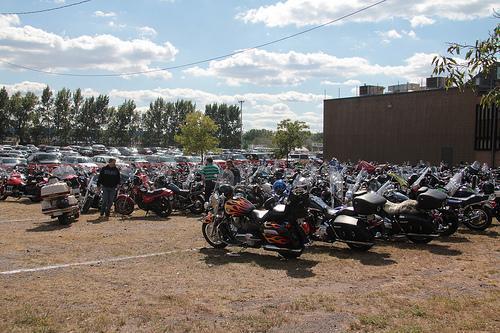How many buildings are abutting the lot, near the motorcycles?
Give a very brief answer. 1. 